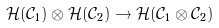<formula> <loc_0><loc_0><loc_500><loc_500>\mathcal { H } ( \mathcal { C } _ { 1 } ) \otimes \mathcal { H } ( \mathcal { C } _ { 2 } ) \to \mathcal { H } ( \mathcal { C } _ { 1 } \otimes \mathcal { C } _ { 2 } )</formula> 